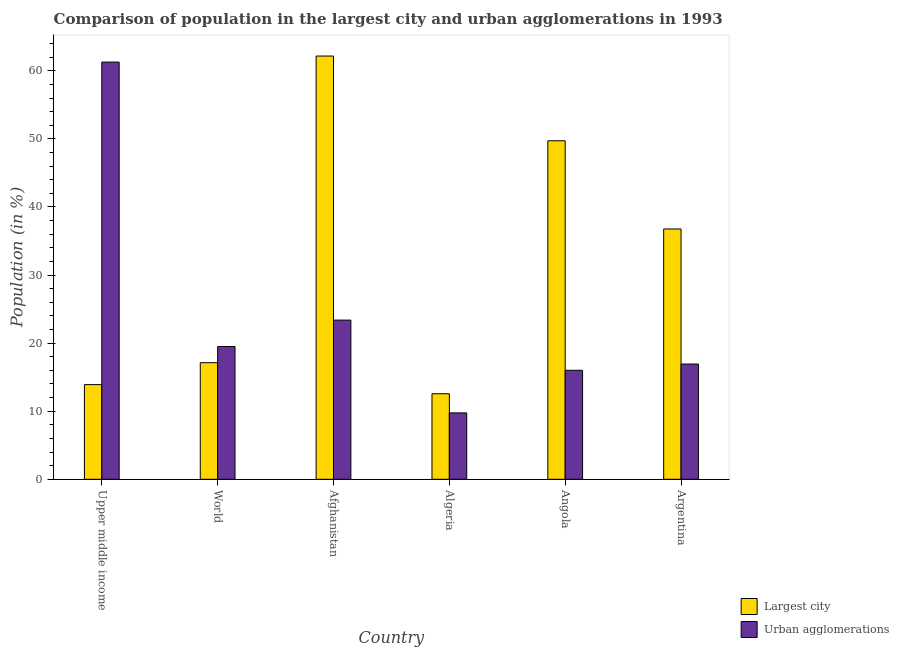How many different coloured bars are there?
Ensure brevity in your answer.  2. Are the number of bars on each tick of the X-axis equal?
Ensure brevity in your answer.  Yes. How many bars are there on the 1st tick from the right?
Your answer should be very brief. 2. What is the label of the 3rd group of bars from the left?
Offer a very short reply. Afghanistan. What is the population in urban agglomerations in Angola?
Ensure brevity in your answer.  16.01. Across all countries, what is the maximum population in urban agglomerations?
Your response must be concise. 61.29. Across all countries, what is the minimum population in urban agglomerations?
Provide a short and direct response. 9.75. In which country was the population in the largest city maximum?
Keep it short and to the point. Afghanistan. In which country was the population in the largest city minimum?
Give a very brief answer. Algeria. What is the total population in the largest city in the graph?
Provide a short and direct response. 192.27. What is the difference between the population in the largest city in Algeria and that in Argentina?
Provide a succinct answer. -24.21. What is the difference between the population in urban agglomerations in Angola and the population in the largest city in Argentina?
Offer a terse response. -20.76. What is the average population in the largest city per country?
Your answer should be very brief. 32.04. What is the difference between the population in the largest city and population in urban agglomerations in Upper middle income?
Offer a terse response. -47.38. In how many countries, is the population in the largest city greater than 60 %?
Offer a very short reply. 1. What is the ratio of the population in urban agglomerations in Algeria to that in World?
Your answer should be very brief. 0.5. Is the population in urban agglomerations in Angola less than that in Argentina?
Keep it short and to the point. Yes. Is the difference between the population in urban agglomerations in Afghanistan and Angola greater than the difference between the population in the largest city in Afghanistan and Angola?
Offer a very short reply. No. What is the difference between the highest and the second highest population in the largest city?
Your response must be concise. 12.45. What is the difference between the highest and the lowest population in the largest city?
Ensure brevity in your answer.  49.61. What does the 2nd bar from the left in World represents?
Make the answer very short. Urban agglomerations. What does the 1st bar from the right in Argentina represents?
Ensure brevity in your answer.  Urban agglomerations. Are all the bars in the graph horizontal?
Give a very brief answer. No. How many countries are there in the graph?
Offer a very short reply. 6. Are the values on the major ticks of Y-axis written in scientific E-notation?
Keep it short and to the point. No. Does the graph contain grids?
Provide a short and direct response. No. Where does the legend appear in the graph?
Make the answer very short. Bottom right. How many legend labels are there?
Provide a short and direct response. 2. What is the title of the graph?
Your answer should be compact. Comparison of population in the largest city and urban agglomerations in 1993. What is the Population (in %) of Largest city in Upper middle income?
Give a very brief answer. 13.91. What is the Population (in %) of Urban agglomerations in Upper middle income?
Make the answer very short. 61.29. What is the Population (in %) in Largest city in World?
Offer a very short reply. 17.13. What is the Population (in %) of Urban agglomerations in World?
Offer a very short reply. 19.51. What is the Population (in %) of Largest city in Afghanistan?
Provide a short and direct response. 62.18. What is the Population (in %) of Urban agglomerations in Afghanistan?
Provide a short and direct response. 23.38. What is the Population (in %) of Largest city in Algeria?
Your response must be concise. 12.57. What is the Population (in %) in Urban agglomerations in Algeria?
Provide a short and direct response. 9.75. What is the Population (in %) of Largest city in Angola?
Keep it short and to the point. 49.73. What is the Population (in %) in Urban agglomerations in Angola?
Keep it short and to the point. 16.01. What is the Population (in %) of Largest city in Argentina?
Give a very brief answer. 36.77. What is the Population (in %) in Urban agglomerations in Argentina?
Your answer should be very brief. 16.93. Across all countries, what is the maximum Population (in %) in Largest city?
Provide a short and direct response. 62.18. Across all countries, what is the maximum Population (in %) in Urban agglomerations?
Provide a short and direct response. 61.29. Across all countries, what is the minimum Population (in %) of Largest city?
Give a very brief answer. 12.57. Across all countries, what is the minimum Population (in %) of Urban agglomerations?
Provide a short and direct response. 9.75. What is the total Population (in %) of Largest city in the graph?
Ensure brevity in your answer.  192.27. What is the total Population (in %) in Urban agglomerations in the graph?
Give a very brief answer. 146.87. What is the difference between the Population (in %) of Largest city in Upper middle income and that in World?
Provide a succinct answer. -3.22. What is the difference between the Population (in %) in Urban agglomerations in Upper middle income and that in World?
Your answer should be compact. 41.78. What is the difference between the Population (in %) in Largest city in Upper middle income and that in Afghanistan?
Offer a very short reply. -48.27. What is the difference between the Population (in %) of Urban agglomerations in Upper middle income and that in Afghanistan?
Keep it short and to the point. 37.91. What is the difference between the Population (in %) in Largest city in Upper middle income and that in Algeria?
Keep it short and to the point. 1.34. What is the difference between the Population (in %) in Urban agglomerations in Upper middle income and that in Algeria?
Make the answer very short. 51.54. What is the difference between the Population (in %) in Largest city in Upper middle income and that in Angola?
Give a very brief answer. -35.82. What is the difference between the Population (in %) in Urban agglomerations in Upper middle income and that in Angola?
Ensure brevity in your answer.  45.28. What is the difference between the Population (in %) in Largest city in Upper middle income and that in Argentina?
Keep it short and to the point. -22.86. What is the difference between the Population (in %) of Urban agglomerations in Upper middle income and that in Argentina?
Your answer should be very brief. 44.36. What is the difference between the Population (in %) in Largest city in World and that in Afghanistan?
Make the answer very short. -45.05. What is the difference between the Population (in %) of Urban agglomerations in World and that in Afghanistan?
Your answer should be compact. -3.88. What is the difference between the Population (in %) in Largest city in World and that in Algeria?
Keep it short and to the point. 4.56. What is the difference between the Population (in %) of Urban agglomerations in World and that in Algeria?
Your answer should be very brief. 9.75. What is the difference between the Population (in %) of Largest city in World and that in Angola?
Your response must be concise. -32.6. What is the difference between the Population (in %) in Urban agglomerations in World and that in Angola?
Ensure brevity in your answer.  3.5. What is the difference between the Population (in %) in Largest city in World and that in Argentina?
Your answer should be very brief. -19.65. What is the difference between the Population (in %) of Urban agglomerations in World and that in Argentina?
Keep it short and to the point. 2.58. What is the difference between the Population (in %) in Largest city in Afghanistan and that in Algeria?
Offer a very short reply. 49.61. What is the difference between the Population (in %) of Urban agglomerations in Afghanistan and that in Algeria?
Give a very brief answer. 13.63. What is the difference between the Population (in %) in Largest city in Afghanistan and that in Angola?
Keep it short and to the point. 12.45. What is the difference between the Population (in %) in Urban agglomerations in Afghanistan and that in Angola?
Keep it short and to the point. 7.37. What is the difference between the Population (in %) of Largest city in Afghanistan and that in Argentina?
Provide a short and direct response. 25.4. What is the difference between the Population (in %) of Urban agglomerations in Afghanistan and that in Argentina?
Keep it short and to the point. 6.46. What is the difference between the Population (in %) in Largest city in Algeria and that in Angola?
Provide a short and direct response. -37.16. What is the difference between the Population (in %) in Urban agglomerations in Algeria and that in Angola?
Offer a terse response. -6.26. What is the difference between the Population (in %) of Largest city in Algeria and that in Argentina?
Keep it short and to the point. -24.21. What is the difference between the Population (in %) of Urban agglomerations in Algeria and that in Argentina?
Keep it short and to the point. -7.18. What is the difference between the Population (in %) in Largest city in Angola and that in Argentina?
Make the answer very short. 12.96. What is the difference between the Population (in %) of Urban agglomerations in Angola and that in Argentina?
Your answer should be very brief. -0.92. What is the difference between the Population (in %) of Largest city in Upper middle income and the Population (in %) of Urban agglomerations in World?
Offer a very short reply. -5.6. What is the difference between the Population (in %) in Largest city in Upper middle income and the Population (in %) in Urban agglomerations in Afghanistan?
Provide a succinct answer. -9.48. What is the difference between the Population (in %) in Largest city in Upper middle income and the Population (in %) in Urban agglomerations in Algeria?
Your answer should be very brief. 4.15. What is the difference between the Population (in %) of Largest city in Upper middle income and the Population (in %) of Urban agglomerations in Angola?
Provide a succinct answer. -2.1. What is the difference between the Population (in %) of Largest city in Upper middle income and the Population (in %) of Urban agglomerations in Argentina?
Provide a succinct answer. -3.02. What is the difference between the Population (in %) of Largest city in World and the Population (in %) of Urban agglomerations in Afghanistan?
Your response must be concise. -6.26. What is the difference between the Population (in %) in Largest city in World and the Population (in %) in Urban agglomerations in Algeria?
Offer a terse response. 7.37. What is the difference between the Population (in %) in Largest city in World and the Population (in %) in Urban agglomerations in Angola?
Offer a very short reply. 1.12. What is the difference between the Population (in %) in Largest city in World and the Population (in %) in Urban agglomerations in Argentina?
Ensure brevity in your answer.  0.2. What is the difference between the Population (in %) of Largest city in Afghanistan and the Population (in %) of Urban agglomerations in Algeria?
Offer a very short reply. 52.42. What is the difference between the Population (in %) of Largest city in Afghanistan and the Population (in %) of Urban agglomerations in Angola?
Your answer should be very brief. 46.17. What is the difference between the Population (in %) of Largest city in Afghanistan and the Population (in %) of Urban agglomerations in Argentina?
Your response must be concise. 45.25. What is the difference between the Population (in %) of Largest city in Algeria and the Population (in %) of Urban agglomerations in Angola?
Offer a terse response. -3.44. What is the difference between the Population (in %) in Largest city in Algeria and the Population (in %) in Urban agglomerations in Argentina?
Offer a terse response. -4.36. What is the difference between the Population (in %) in Largest city in Angola and the Population (in %) in Urban agglomerations in Argentina?
Your answer should be compact. 32.8. What is the average Population (in %) in Largest city per country?
Your answer should be compact. 32.04. What is the average Population (in %) of Urban agglomerations per country?
Make the answer very short. 24.48. What is the difference between the Population (in %) of Largest city and Population (in %) of Urban agglomerations in Upper middle income?
Provide a short and direct response. -47.38. What is the difference between the Population (in %) in Largest city and Population (in %) in Urban agglomerations in World?
Your answer should be very brief. -2.38. What is the difference between the Population (in %) of Largest city and Population (in %) of Urban agglomerations in Afghanistan?
Offer a terse response. 38.79. What is the difference between the Population (in %) in Largest city and Population (in %) in Urban agglomerations in Algeria?
Ensure brevity in your answer.  2.81. What is the difference between the Population (in %) in Largest city and Population (in %) in Urban agglomerations in Angola?
Make the answer very short. 33.72. What is the difference between the Population (in %) in Largest city and Population (in %) in Urban agglomerations in Argentina?
Your answer should be very brief. 19.84. What is the ratio of the Population (in %) of Largest city in Upper middle income to that in World?
Ensure brevity in your answer.  0.81. What is the ratio of the Population (in %) of Urban agglomerations in Upper middle income to that in World?
Give a very brief answer. 3.14. What is the ratio of the Population (in %) in Largest city in Upper middle income to that in Afghanistan?
Give a very brief answer. 0.22. What is the ratio of the Population (in %) in Urban agglomerations in Upper middle income to that in Afghanistan?
Offer a very short reply. 2.62. What is the ratio of the Population (in %) in Largest city in Upper middle income to that in Algeria?
Keep it short and to the point. 1.11. What is the ratio of the Population (in %) of Urban agglomerations in Upper middle income to that in Algeria?
Your response must be concise. 6.29. What is the ratio of the Population (in %) of Largest city in Upper middle income to that in Angola?
Ensure brevity in your answer.  0.28. What is the ratio of the Population (in %) of Urban agglomerations in Upper middle income to that in Angola?
Ensure brevity in your answer.  3.83. What is the ratio of the Population (in %) of Largest city in Upper middle income to that in Argentina?
Give a very brief answer. 0.38. What is the ratio of the Population (in %) of Urban agglomerations in Upper middle income to that in Argentina?
Offer a terse response. 3.62. What is the ratio of the Population (in %) of Largest city in World to that in Afghanistan?
Your response must be concise. 0.28. What is the ratio of the Population (in %) in Urban agglomerations in World to that in Afghanistan?
Provide a short and direct response. 0.83. What is the ratio of the Population (in %) of Largest city in World to that in Algeria?
Provide a short and direct response. 1.36. What is the ratio of the Population (in %) in Urban agglomerations in World to that in Algeria?
Keep it short and to the point. 2. What is the ratio of the Population (in %) of Largest city in World to that in Angola?
Your response must be concise. 0.34. What is the ratio of the Population (in %) in Urban agglomerations in World to that in Angola?
Keep it short and to the point. 1.22. What is the ratio of the Population (in %) in Largest city in World to that in Argentina?
Your answer should be very brief. 0.47. What is the ratio of the Population (in %) in Urban agglomerations in World to that in Argentina?
Your answer should be very brief. 1.15. What is the ratio of the Population (in %) of Largest city in Afghanistan to that in Algeria?
Your response must be concise. 4.95. What is the ratio of the Population (in %) of Urban agglomerations in Afghanistan to that in Algeria?
Offer a very short reply. 2.4. What is the ratio of the Population (in %) in Largest city in Afghanistan to that in Angola?
Your answer should be very brief. 1.25. What is the ratio of the Population (in %) of Urban agglomerations in Afghanistan to that in Angola?
Your answer should be very brief. 1.46. What is the ratio of the Population (in %) in Largest city in Afghanistan to that in Argentina?
Ensure brevity in your answer.  1.69. What is the ratio of the Population (in %) in Urban agglomerations in Afghanistan to that in Argentina?
Provide a succinct answer. 1.38. What is the ratio of the Population (in %) of Largest city in Algeria to that in Angola?
Your answer should be compact. 0.25. What is the ratio of the Population (in %) in Urban agglomerations in Algeria to that in Angola?
Offer a terse response. 0.61. What is the ratio of the Population (in %) of Largest city in Algeria to that in Argentina?
Give a very brief answer. 0.34. What is the ratio of the Population (in %) of Urban agglomerations in Algeria to that in Argentina?
Give a very brief answer. 0.58. What is the ratio of the Population (in %) of Largest city in Angola to that in Argentina?
Your answer should be very brief. 1.35. What is the ratio of the Population (in %) of Urban agglomerations in Angola to that in Argentina?
Ensure brevity in your answer.  0.95. What is the difference between the highest and the second highest Population (in %) in Largest city?
Your answer should be very brief. 12.45. What is the difference between the highest and the second highest Population (in %) in Urban agglomerations?
Keep it short and to the point. 37.91. What is the difference between the highest and the lowest Population (in %) in Largest city?
Your response must be concise. 49.61. What is the difference between the highest and the lowest Population (in %) in Urban agglomerations?
Make the answer very short. 51.54. 